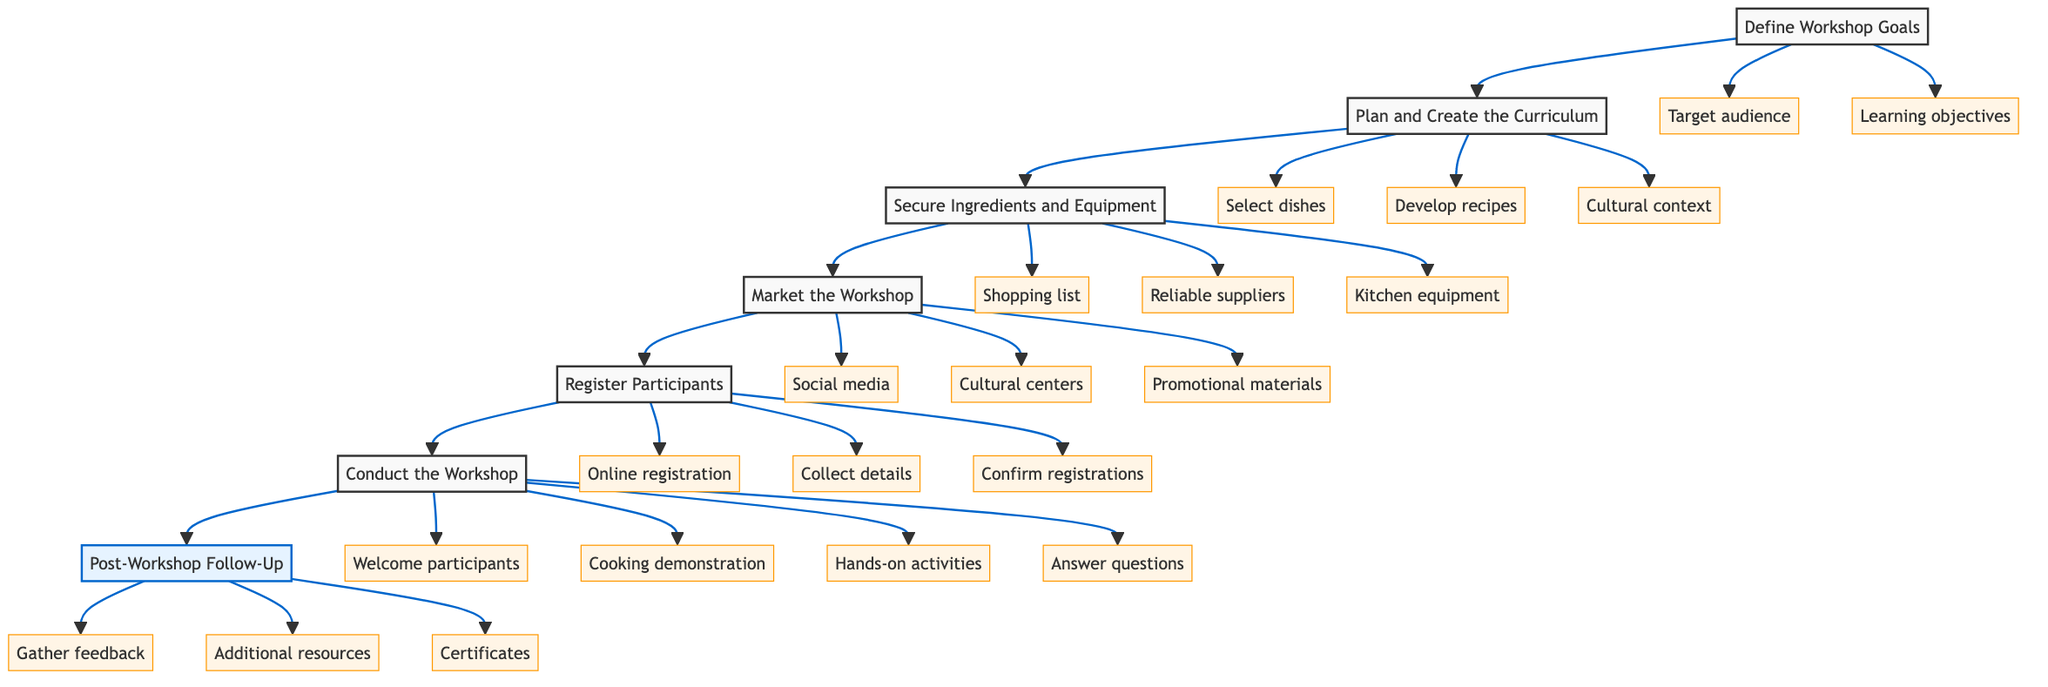What is the first step in the workflow? The diagram shows the workflow starting with the node labeled "Define Workshop Goals," indicating that this is the first step in the process.
Answer: Define Workshop Goals How many major steps are in the workflow? The flowchart has seven major steps listed from "Define Workshop Goals" to "Post-Workshop Follow-Up." Counting each distinct step provides the total.
Answer: 7 Which step follows "Market the Workshop"? From the flow of the diagram, "Register Participants" is directly connected to "Market the Workshop," indicating it is the next step in the sequence.
Answer: Register Participants What are the three elements of "Conduct the Workshop"? The elements connected to the "Conduct the Workshop" step include "Welcome participants," "Cooking demonstration," and "Hands-on activities." Identifying these elements provides the answer.
Answer: Welcome participants, Cooking demonstration, Hands-on activities Which step includes collecting participant details? In the diagram, the step "Register Participants" is connected to an element that specifically states "Collect participant details." This indicates that this task is part of the registration process.
Answer: Register Participants What is the final step of the workflow? The last major step in the workflow is labeled "Post-Workshop Follow-Up," which implies this is the concluding phase of the process.
Answer: Post-Workshop Follow-Up What are the three types of promotion used in "Market the Workshop"? The step "Market the Workshop" has three elements: "Social media," "Cultural centers," and "Promotional materials." These represent the methods of promotion.
Answer: Social media, Cultural centers, Promotional materials In which step do participants receive certificates? In the workflow, the activity of providing certificates is part of the "Post-Workshop Follow-Up" step, where the elements include things related to post-event actions.
Answer: Post-Workshop Follow-Up How is cultural context incorporated in the workshop? The element "Cultural context" is included under the step "Plan and Create the Curriculum," indicating that it is integrated during the planning phase of the workshop.
Answer: Plan and Create the Curriculum 